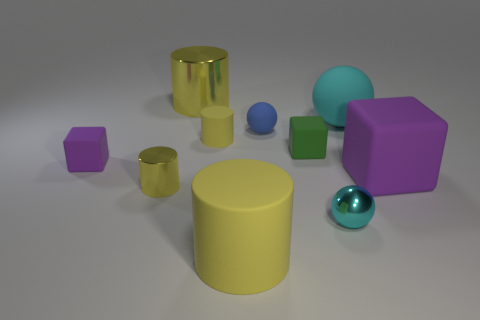Subtract all small cyan spheres. How many spheres are left? 2 Subtract all blue spheres. How many spheres are left? 2 Subtract 0 red spheres. How many objects are left? 10 Subtract all blocks. How many objects are left? 7 Subtract 1 balls. How many balls are left? 2 Subtract all purple cylinders. Subtract all red balls. How many cylinders are left? 4 Subtract all cyan spheres. How many cyan cylinders are left? 0 Subtract all blocks. Subtract all tiny gray rubber cubes. How many objects are left? 7 Add 5 large metallic objects. How many large metallic objects are left? 6 Add 9 red matte things. How many red matte things exist? 9 